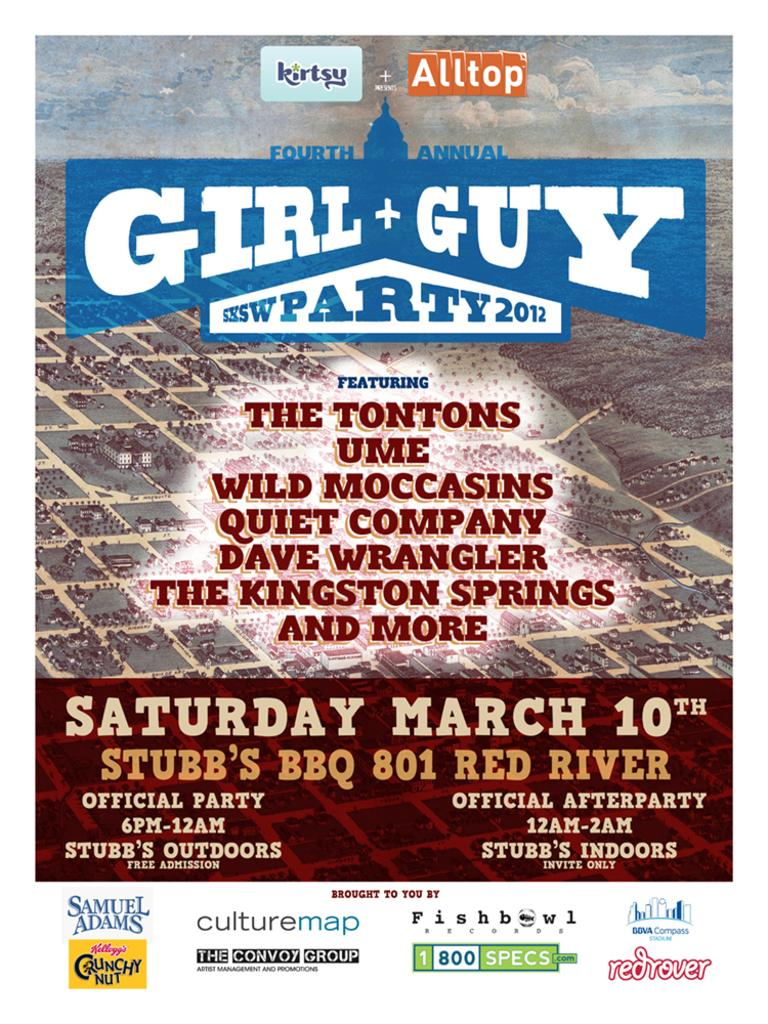<image>
Offer a succinct explanation of the picture presented. A flyer promoting a girl and guy party shows that it has been scheduled for Saturday, March 10th. 